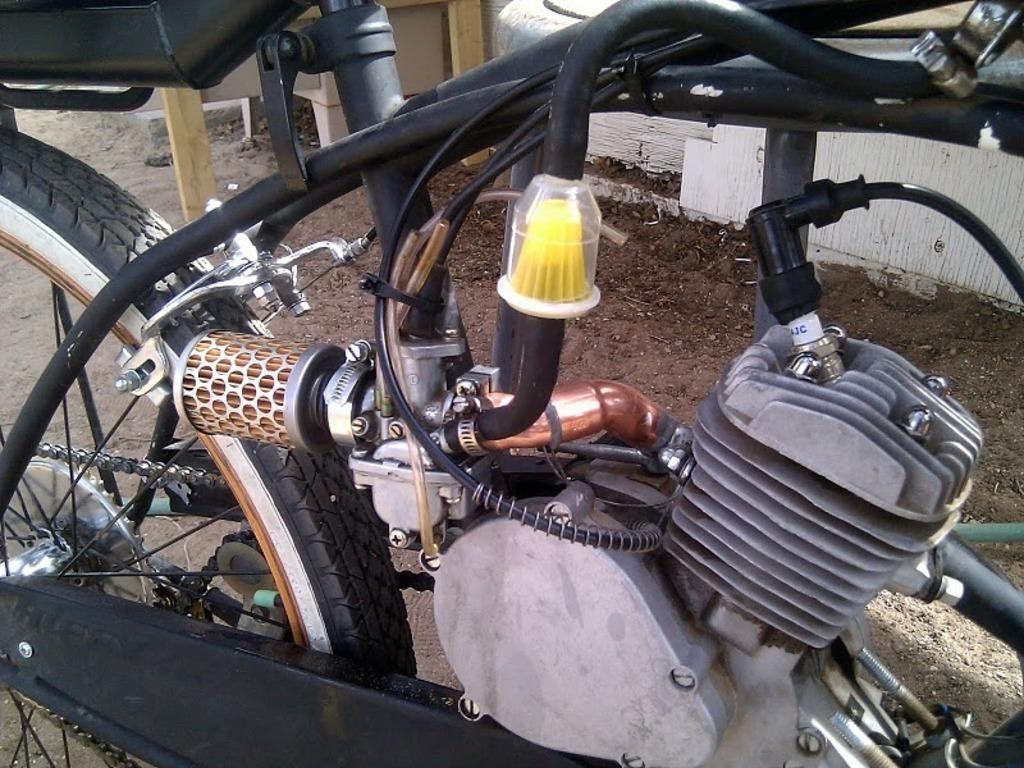What type of vehicle is in the image? There is a motorcycle in the image. What colors can be seen on the motorcycle? The motorcycle is black and ash colored. What is the condition of the ground near the motorcycle? There is mud visible near the motorcycle. What type of structure is present in the background of the image? There is a white color wall in the image. How does the motorcycle measure the health of the rider? The motorcycle does not measure the health of the rider; it is a vehicle, not a medical device. 